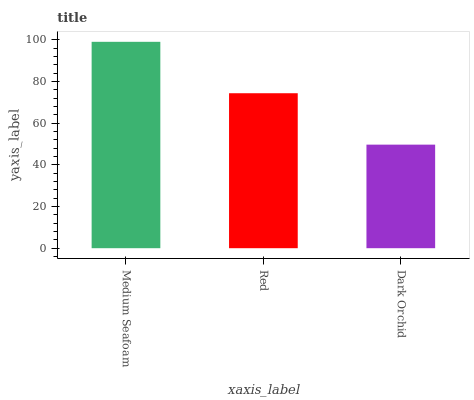Is Dark Orchid the minimum?
Answer yes or no. Yes. Is Medium Seafoam the maximum?
Answer yes or no. Yes. Is Red the minimum?
Answer yes or no. No. Is Red the maximum?
Answer yes or no. No. Is Medium Seafoam greater than Red?
Answer yes or no. Yes. Is Red less than Medium Seafoam?
Answer yes or no. Yes. Is Red greater than Medium Seafoam?
Answer yes or no. No. Is Medium Seafoam less than Red?
Answer yes or no. No. Is Red the high median?
Answer yes or no. Yes. Is Red the low median?
Answer yes or no. Yes. Is Dark Orchid the high median?
Answer yes or no. No. Is Medium Seafoam the low median?
Answer yes or no. No. 